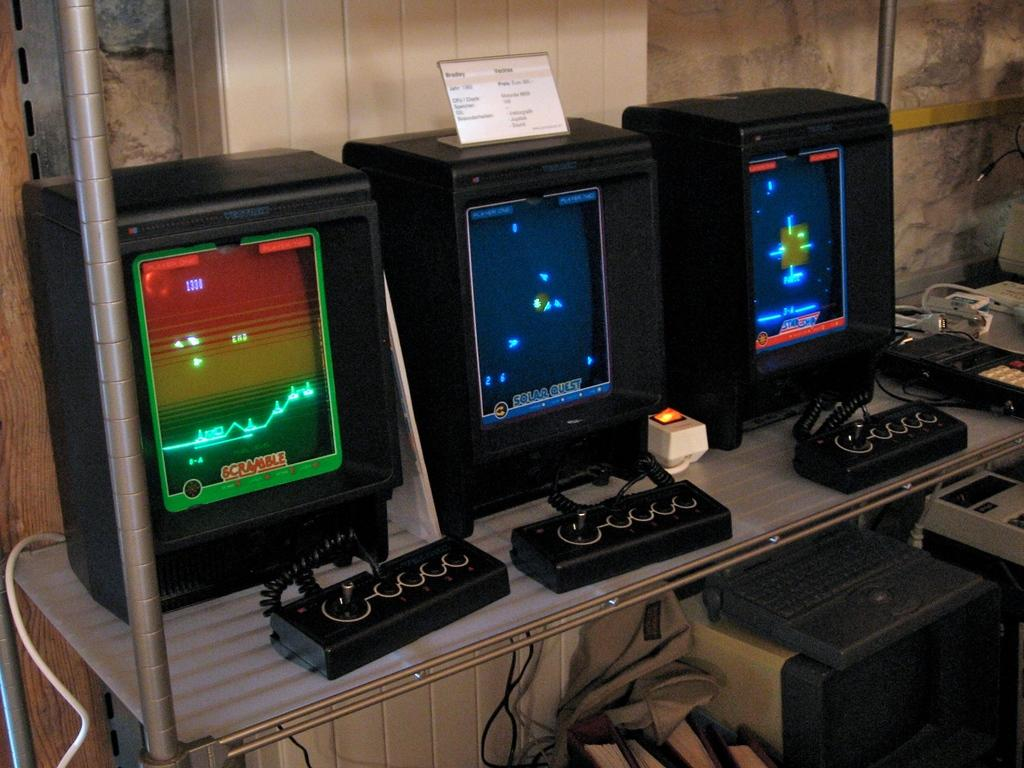What type of electronic devices can be seen in the image? There are monitors and switch boards in the image. What other equipment is present in the image? There are machines and wires in the image. What structural element is visible in the image? There is a pole and a wall in the image. Can you describe an object on one of the monitors? There is a white color object on a monitor. What theory is being discussed by the kitten in the image? There is no kitten present in the image, so no theory can be discussed. Can you tell me what type of cracker is on the switch board in the image? There is no cracker present on the switch board or anywhere else in the image. 